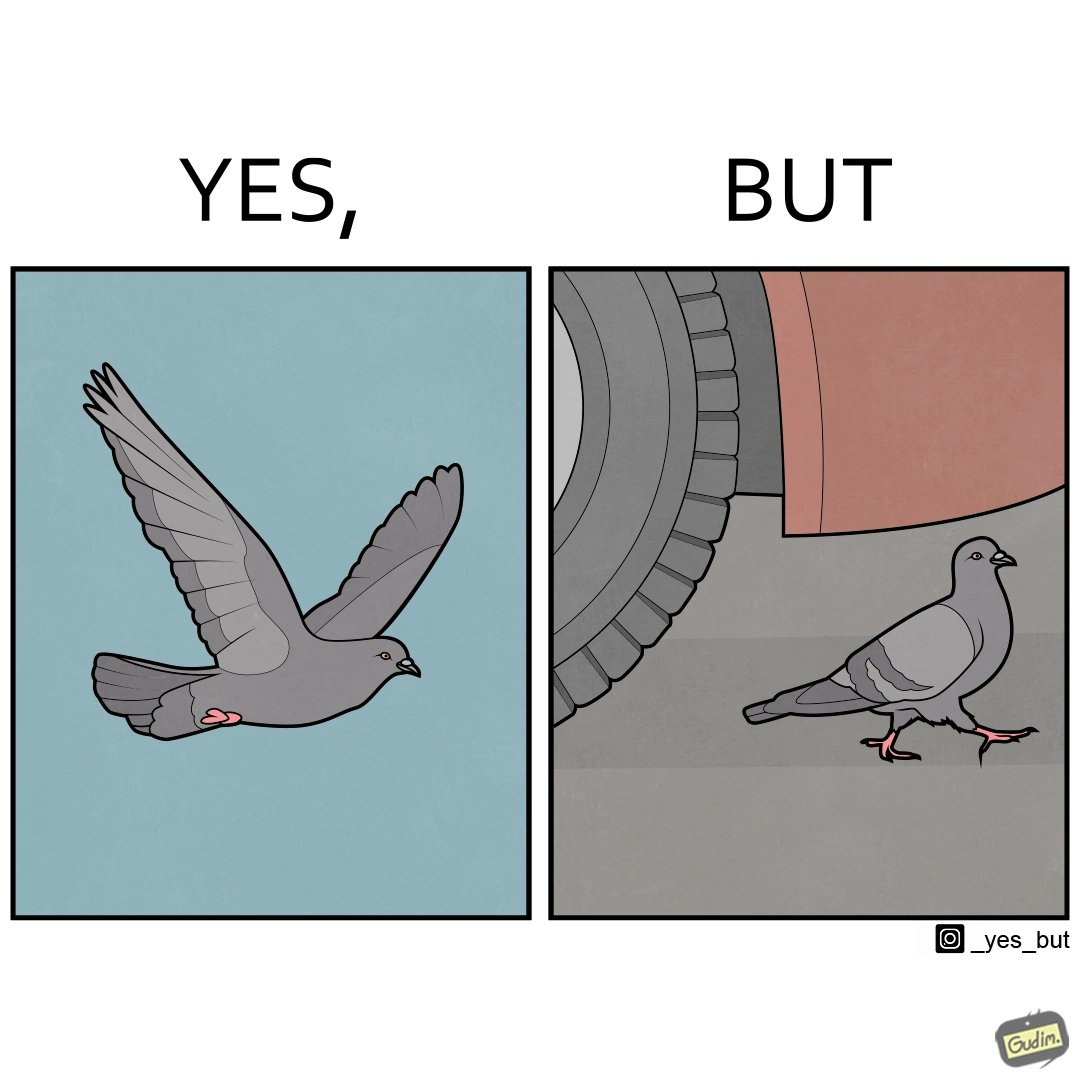What is the satirical meaning behind this image? The image is ironic, because even when the pigeon has wings to fly it is walking even when it seems threatening to its life 